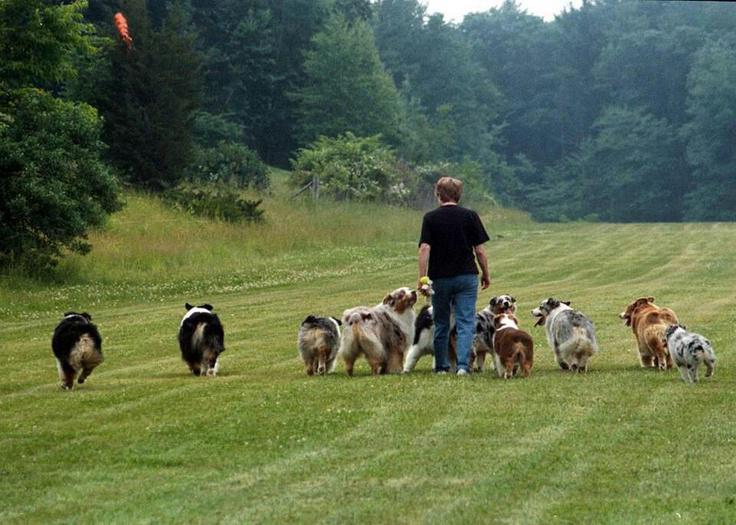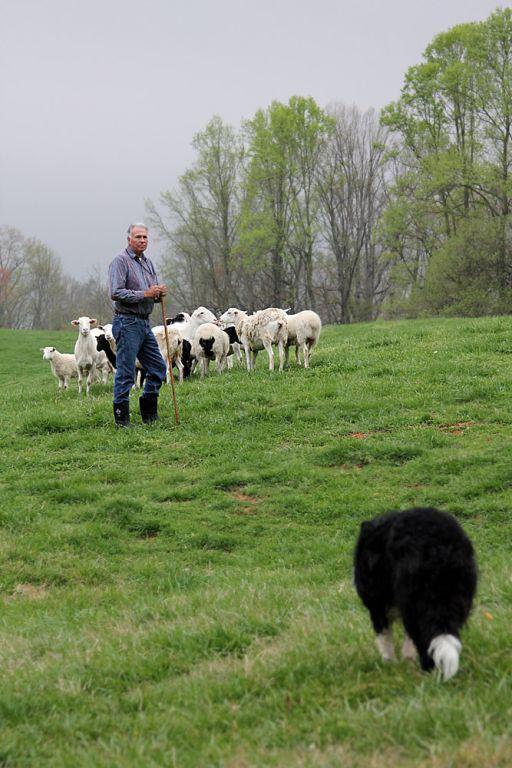The first image is the image on the left, the second image is the image on the right. For the images shown, is this caption "In one image, a man is standing in a green, grassy area with multiple dogs and multiple sheep." true? Answer yes or no. No. 